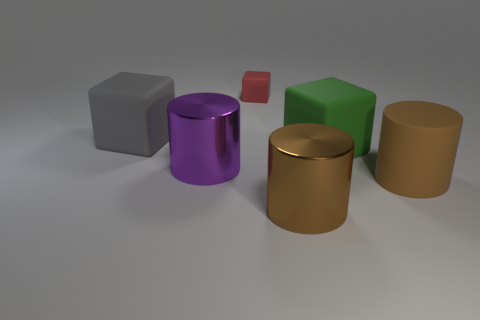Is there any other thing that has the same size as the red matte block?
Offer a very short reply. No. What is the size of the red thing that is the same shape as the gray object?
Make the answer very short. Small. There is a thing that is both on the right side of the brown shiny cylinder and in front of the green cube; what is it made of?
Ensure brevity in your answer.  Rubber. There is a shiny cylinder that is right of the tiny matte block; is it the same color as the big matte cylinder?
Your answer should be very brief. Yes. Does the tiny rubber object have the same color as the large cylinder behind the big brown rubber cylinder?
Provide a short and direct response. No. Are there any red things behind the gray rubber thing?
Your response must be concise. Yes. Is the material of the gray object the same as the green cube?
Your answer should be very brief. Yes. There is a purple object that is the same size as the gray matte thing; what is it made of?
Provide a short and direct response. Metal. How many things are matte blocks that are in front of the big gray rubber cube or tiny things?
Make the answer very short. 2. Are there the same number of large purple metallic cylinders that are left of the big brown metal thing and big green rubber things?
Ensure brevity in your answer.  Yes. 